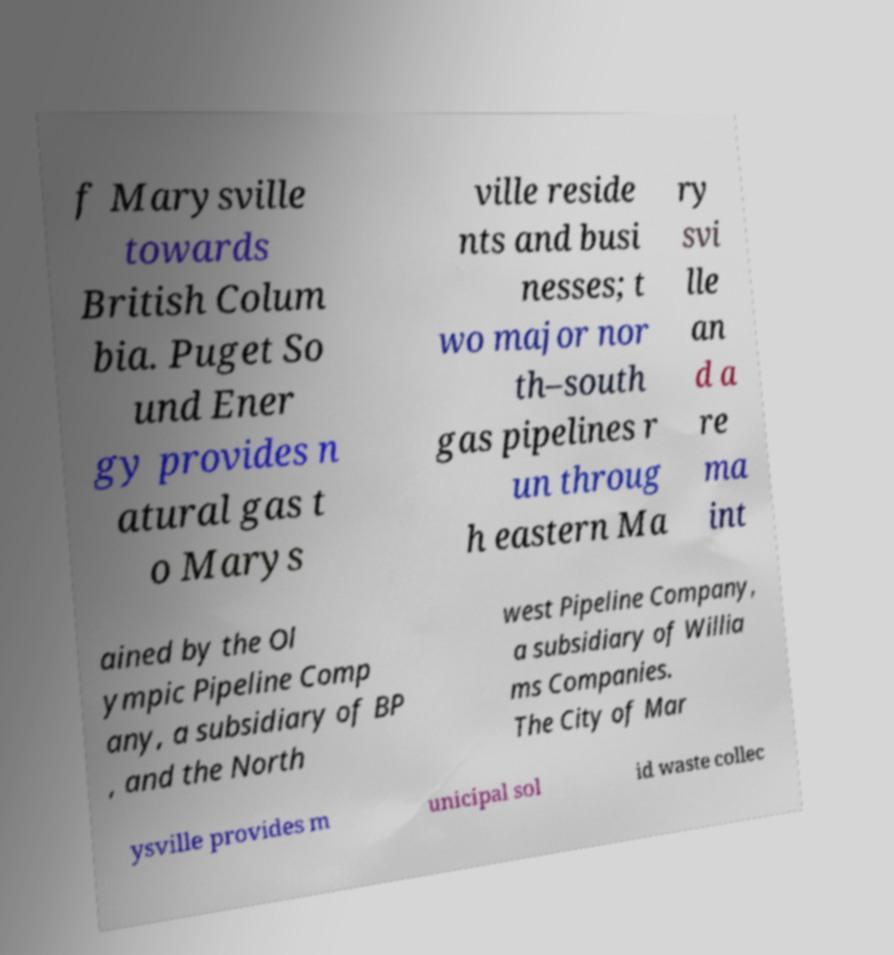Could you assist in decoding the text presented in this image and type it out clearly? f Marysville towards British Colum bia. Puget So und Ener gy provides n atural gas t o Marys ville reside nts and busi nesses; t wo major nor th–south gas pipelines r un throug h eastern Ma ry svi lle an d a re ma int ained by the Ol ympic Pipeline Comp any, a subsidiary of BP , and the North west Pipeline Company, a subsidiary of Willia ms Companies. The City of Mar ysville provides m unicipal sol id waste collec 